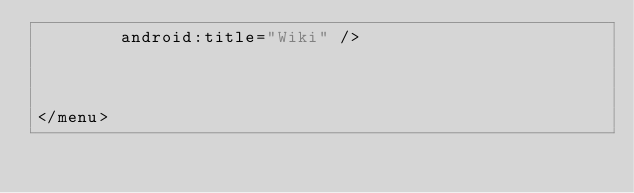Convert code to text. <code><loc_0><loc_0><loc_500><loc_500><_XML_>        android:title="Wiki" />



</menu>
</code> 